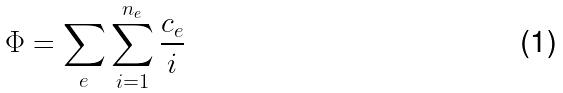Convert formula to latex. <formula><loc_0><loc_0><loc_500><loc_500>\Phi = \sum _ { e } \sum _ { i = 1 } ^ { n _ { e } } \frac { c _ { e } } { i }</formula> 